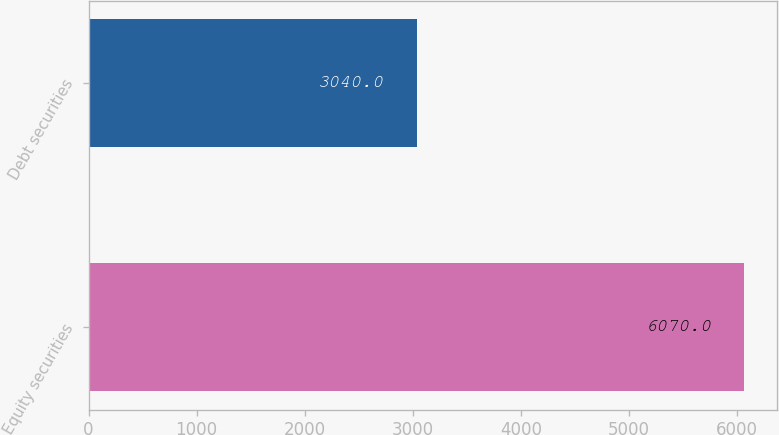Convert chart to OTSL. <chart><loc_0><loc_0><loc_500><loc_500><bar_chart><fcel>Equity securities<fcel>Debt securities<nl><fcel>6070<fcel>3040<nl></chart> 